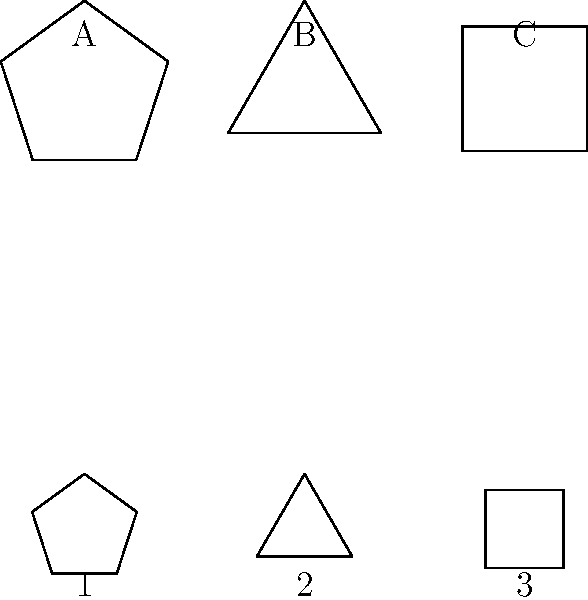Match the neurotransmitter molecules (1, 2, 3) with their corresponding receptor shapes (A, B, C) based on the principle of molecular congruence. Which combination correctly aligns all three pairs? To solve this question, we need to understand the principle of molecular congruence in neurotransmitter-receptor interactions. Here's a step-by-step explanation:

1. Molecular congruence: Neurotransmitters bind to their receptors based on a "lock and key" model, where the shape of the molecule must fit precisely into the receptor's binding site.

2. Analyze the shapes:
   - Receptor A and Molecule 1 are both pentagons
   - Receptor B and Molecule 2 are both triangles
   - Receptor C and Molecule 3 are both squares

3. Match the shapes:
   - A matches with 1 (pentagons)
   - B matches with 2 (triangles)
   - C matches with 3 (squares)

4. The correct combination that aligns all three pairs is:
   A-1, B-2, C-3

This matching demonstrates how the specificity of neurotransmitter-receptor interactions is based on their complementary shapes, which is crucial for proper synaptic transmission in the nervous system.
Answer: A-1, B-2, C-3 